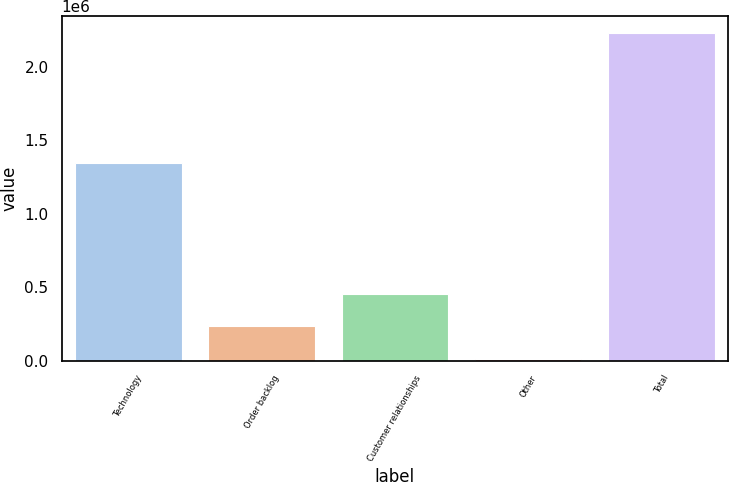Convert chart to OTSL. <chart><loc_0><loc_0><loc_500><loc_500><bar_chart><fcel>Technology<fcel>Order backlog<fcel>Customer relationships<fcel>Other<fcel>Total<nl><fcel>1.34731e+06<fcel>233055<fcel>455238<fcel>10873<fcel>2.2327e+06<nl></chart> 